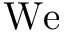Convert formula to latex. <formula><loc_0><loc_0><loc_500><loc_500>W e</formula> 